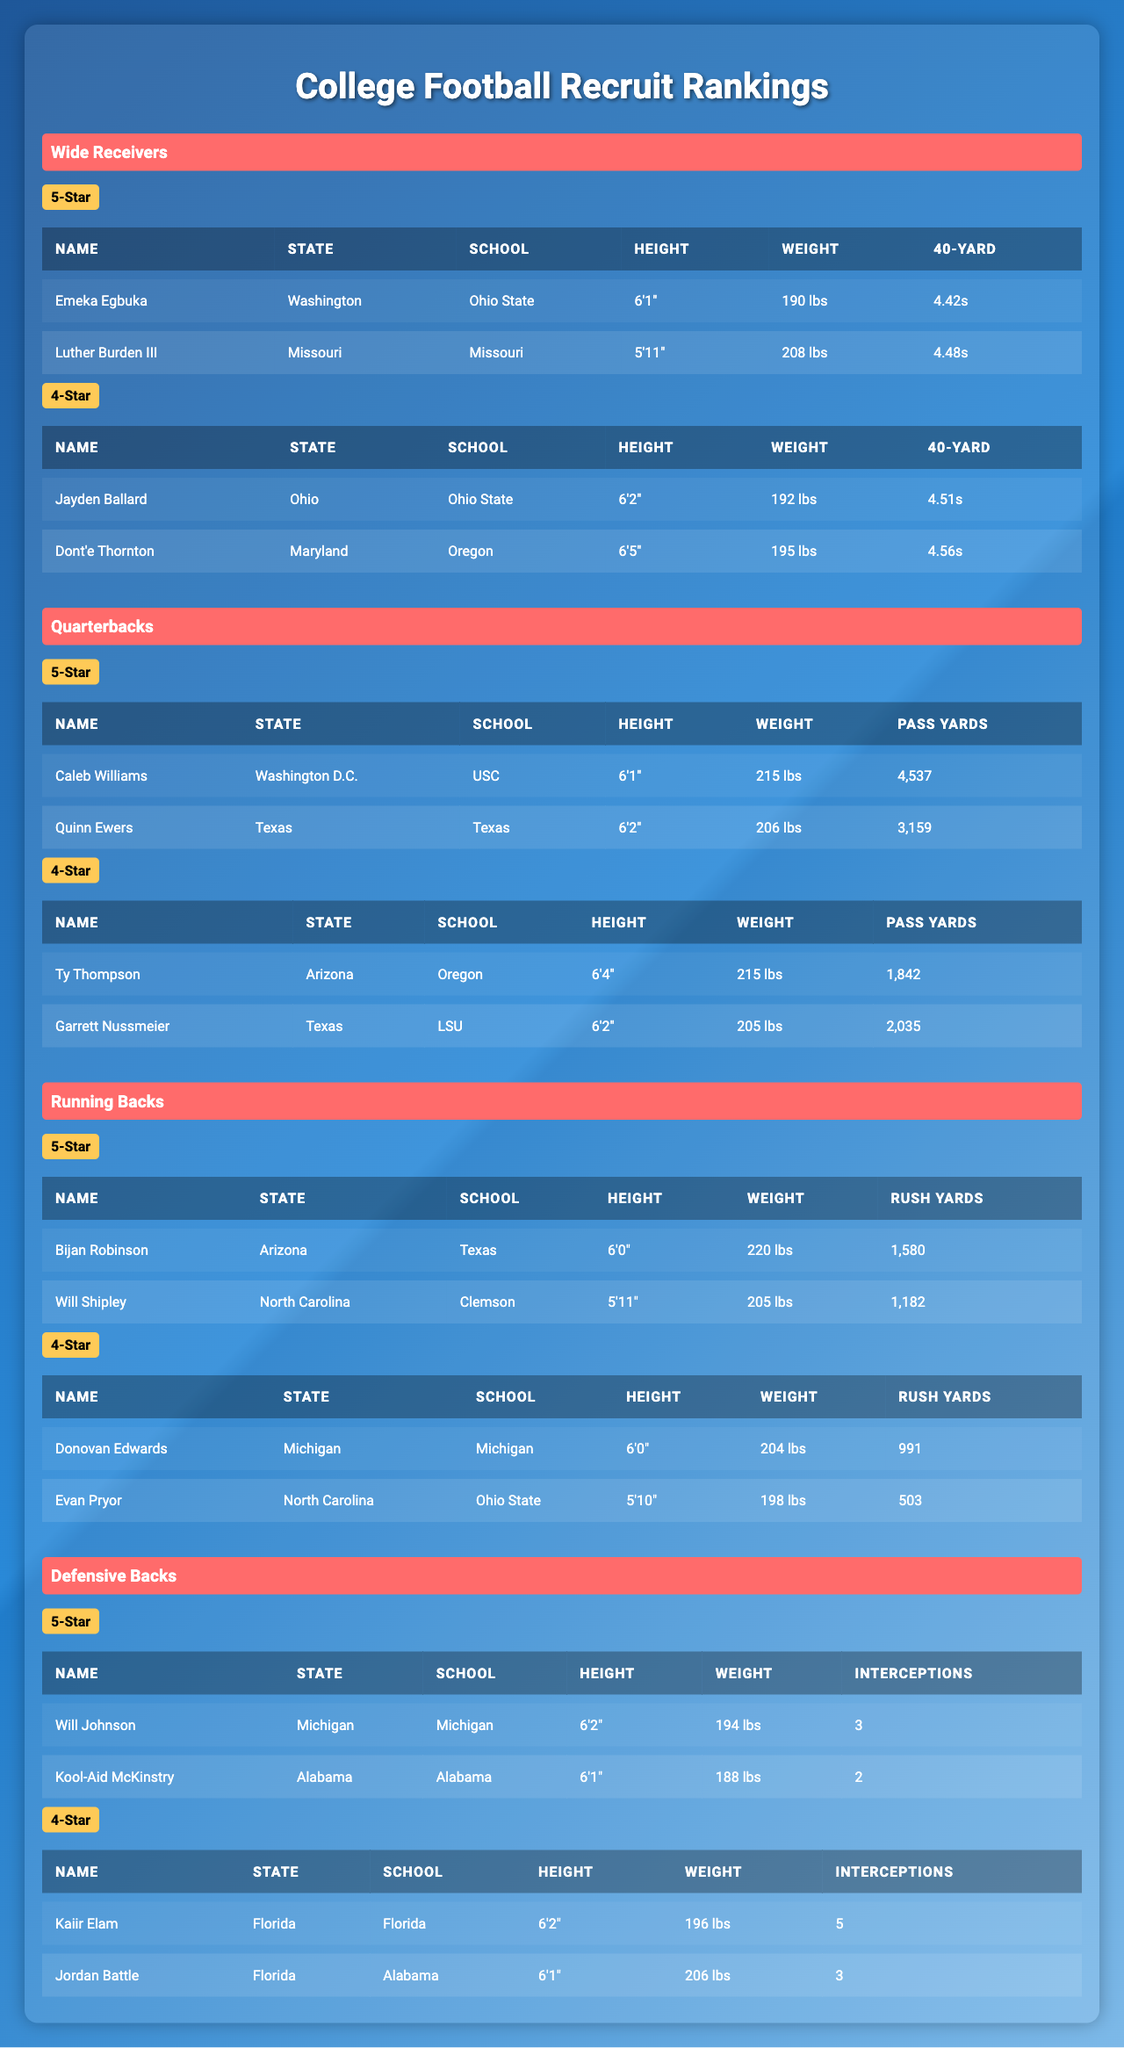What is the height of Emeka Egbuka? The table lists Emeka Egbuka's height within the Wide Receivers section, which clearly states he is 6'1".
Answer: 6'1" Which state has the most 5-star players for Quarterbacks? Looking at the table under Quarterbacks, Washington D.C. and Texas each have one 5-star player, resulting in a tie.
Answer: Washington D.C. and Texas How many rushing yards does Bijan Robinson have? The table under Running Backs indicates that Bijan Robinson has 1,580 rushing yards.
Answer: 1,580 Are there any 4-star Defensive Backs from Texas? Referring to the Defensive Backs section, the data shows there are no 4-star players listed from Texas.
Answer: No What is the average weight of the 5-star Wide Receivers? The weights of the 5-star Wide Receivers are 190 lbs (Emeka Egbuka) and 208 lbs (Luther Burden III). Their total weight is 190 + 208 = 398 lbs, which divided by 2 gives an average weight of 199 lbs.
Answer: 199 lbs How many total players are listed under the Running Backs category? In the Running Backs section, there are two 5-star players (Bijan Robinson and Will Shipley) and two 4-star players (Donovan Edwards and Evan Pryor), making a total of 4 players.
Answer: 4 players Which player has the most interceptions listed? Reviewing the Defensive Backs section, Kaiir Elam has 5 interceptions, which is the highest among the listed players.
Answer: Kaiir Elam Is there a 4-star Wide Receiver from Maryland? The table indicates that there is one 4-star Wide Receiver from Maryland, which is Dont'e Thornton.
Answer: Yes What is the combined Pass Yards of the 5-star Quarterbacks? The 5-star Quarterbacks listed are Caleb Williams with 4,537 yards and Quinn Ewers with 3,159 yards. Adding these gives a total of 4,537 + 3,159 = 7,696 passing yards.
Answer: 7,696 passing yards Which position has the least number of players listed? Reviewing all sections, the Running Backs show a total of 4 players compared to all other positions which have more, indicating Running Backs have the smallest group.
Answer: Running Backs 